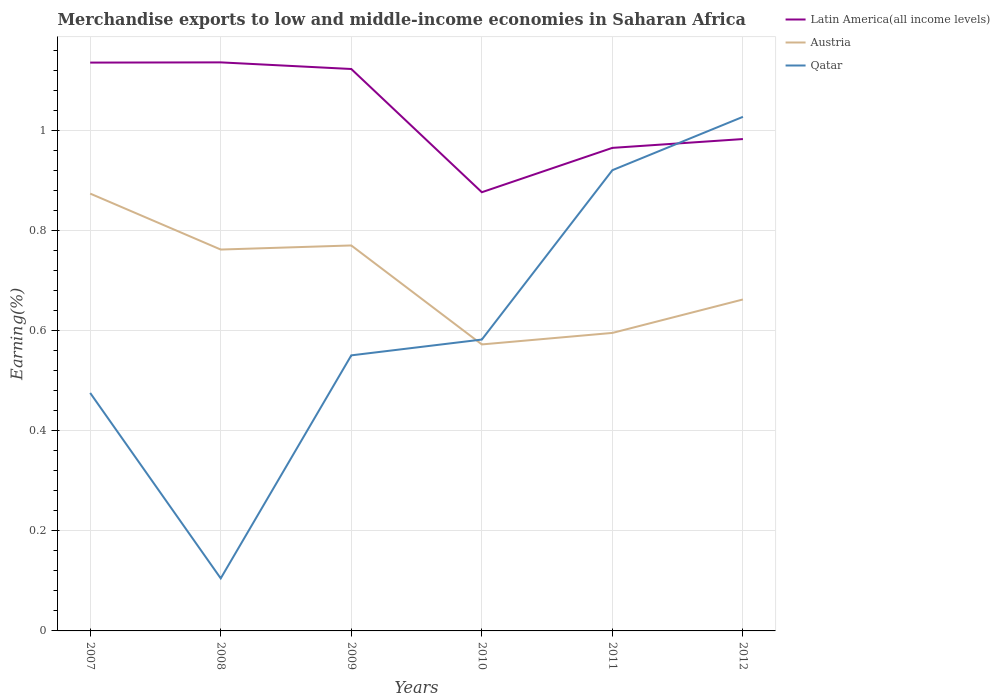Does the line corresponding to Latin America(all income levels) intersect with the line corresponding to Austria?
Provide a succinct answer. No. Is the number of lines equal to the number of legend labels?
Provide a succinct answer. Yes. Across all years, what is the maximum percentage of amount earned from merchandise exports in Qatar?
Your answer should be very brief. 0.11. In which year was the percentage of amount earned from merchandise exports in Austria maximum?
Your answer should be very brief. 2010. What is the total percentage of amount earned from merchandise exports in Austria in the graph?
Offer a very short reply. 0.11. What is the difference between the highest and the second highest percentage of amount earned from merchandise exports in Austria?
Give a very brief answer. 0.3. What is the difference between the highest and the lowest percentage of amount earned from merchandise exports in Austria?
Give a very brief answer. 3. What is the difference between two consecutive major ticks on the Y-axis?
Offer a very short reply. 0.2. Does the graph contain grids?
Provide a succinct answer. Yes. How many legend labels are there?
Provide a short and direct response. 3. What is the title of the graph?
Your answer should be compact. Merchandise exports to low and middle-income economies in Saharan Africa. Does "Hungary" appear as one of the legend labels in the graph?
Ensure brevity in your answer.  No. What is the label or title of the Y-axis?
Your response must be concise. Earning(%). What is the Earning(%) of Latin America(all income levels) in 2007?
Offer a terse response. 1.14. What is the Earning(%) in Austria in 2007?
Offer a terse response. 0.87. What is the Earning(%) in Qatar in 2007?
Ensure brevity in your answer.  0.48. What is the Earning(%) in Latin America(all income levels) in 2008?
Keep it short and to the point. 1.14. What is the Earning(%) in Austria in 2008?
Your answer should be compact. 0.76. What is the Earning(%) of Qatar in 2008?
Keep it short and to the point. 0.11. What is the Earning(%) of Latin America(all income levels) in 2009?
Ensure brevity in your answer.  1.12. What is the Earning(%) of Austria in 2009?
Offer a very short reply. 0.77. What is the Earning(%) of Qatar in 2009?
Offer a very short reply. 0.55. What is the Earning(%) of Latin America(all income levels) in 2010?
Make the answer very short. 0.88. What is the Earning(%) of Austria in 2010?
Your response must be concise. 0.57. What is the Earning(%) in Qatar in 2010?
Provide a short and direct response. 0.58. What is the Earning(%) of Latin America(all income levels) in 2011?
Provide a short and direct response. 0.97. What is the Earning(%) of Austria in 2011?
Offer a very short reply. 0.6. What is the Earning(%) of Qatar in 2011?
Keep it short and to the point. 0.92. What is the Earning(%) of Latin America(all income levels) in 2012?
Provide a short and direct response. 0.98. What is the Earning(%) in Austria in 2012?
Your answer should be compact. 0.66. What is the Earning(%) of Qatar in 2012?
Give a very brief answer. 1.03. Across all years, what is the maximum Earning(%) in Latin America(all income levels)?
Your answer should be very brief. 1.14. Across all years, what is the maximum Earning(%) in Austria?
Make the answer very short. 0.87. Across all years, what is the maximum Earning(%) in Qatar?
Your answer should be compact. 1.03. Across all years, what is the minimum Earning(%) of Latin America(all income levels)?
Provide a short and direct response. 0.88. Across all years, what is the minimum Earning(%) of Austria?
Give a very brief answer. 0.57. Across all years, what is the minimum Earning(%) of Qatar?
Ensure brevity in your answer.  0.11. What is the total Earning(%) of Latin America(all income levels) in the graph?
Provide a succinct answer. 6.22. What is the total Earning(%) of Austria in the graph?
Provide a succinct answer. 4.24. What is the total Earning(%) in Qatar in the graph?
Provide a succinct answer. 3.66. What is the difference between the Earning(%) in Latin America(all income levels) in 2007 and that in 2008?
Provide a short and direct response. -0. What is the difference between the Earning(%) in Austria in 2007 and that in 2008?
Provide a short and direct response. 0.11. What is the difference between the Earning(%) of Qatar in 2007 and that in 2008?
Make the answer very short. 0.37. What is the difference between the Earning(%) of Latin America(all income levels) in 2007 and that in 2009?
Your answer should be compact. 0.01. What is the difference between the Earning(%) of Austria in 2007 and that in 2009?
Keep it short and to the point. 0.1. What is the difference between the Earning(%) in Qatar in 2007 and that in 2009?
Give a very brief answer. -0.08. What is the difference between the Earning(%) in Latin America(all income levels) in 2007 and that in 2010?
Make the answer very short. 0.26. What is the difference between the Earning(%) in Austria in 2007 and that in 2010?
Your answer should be compact. 0.3. What is the difference between the Earning(%) in Qatar in 2007 and that in 2010?
Make the answer very short. -0.11. What is the difference between the Earning(%) in Latin America(all income levels) in 2007 and that in 2011?
Your answer should be compact. 0.17. What is the difference between the Earning(%) in Austria in 2007 and that in 2011?
Make the answer very short. 0.28. What is the difference between the Earning(%) of Qatar in 2007 and that in 2011?
Your response must be concise. -0.45. What is the difference between the Earning(%) of Latin America(all income levels) in 2007 and that in 2012?
Your answer should be very brief. 0.15. What is the difference between the Earning(%) of Austria in 2007 and that in 2012?
Give a very brief answer. 0.21. What is the difference between the Earning(%) in Qatar in 2007 and that in 2012?
Your answer should be compact. -0.55. What is the difference between the Earning(%) of Latin America(all income levels) in 2008 and that in 2009?
Ensure brevity in your answer.  0.01. What is the difference between the Earning(%) in Austria in 2008 and that in 2009?
Provide a succinct answer. -0.01. What is the difference between the Earning(%) of Qatar in 2008 and that in 2009?
Make the answer very short. -0.45. What is the difference between the Earning(%) in Latin America(all income levels) in 2008 and that in 2010?
Provide a short and direct response. 0.26. What is the difference between the Earning(%) of Austria in 2008 and that in 2010?
Keep it short and to the point. 0.19. What is the difference between the Earning(%) of Qatar in 2008 and that in 2010?
Ensure brevity in your answer.  -0.48. What is the difference between the Earning(%) in Latin America(all income levels) in 2008 and that in 2011?
Ensure brevity in your answer.  0.17. What is the difference between the Earning(%) of Austria in 2008 and that in 2011?
Provide a succinct answer. 0.17. What is the difference between the Earning(%) in Qatar in 2008 and that in 2011?
Offer a terse response. -0.82. What is the difference between the Earning(%) of Latin America(all income levels) in 2008 and that in 2012?
Offer a terse response. 0.15. What is the difference between the Earning(%) in Austria in 2008 and that in 2012?
Provide a succinct answer. 0.1. What is the difference between the Earning(%) of Qatar in 2008 and that in 2012?
Your response must be concise. -0.92. What is the difference between the Earning(%) in Latin America(all income levels) in 2009 and that in 2010?
Provide a succinct answer. 0.25. What is the difference between the Earning(%) of Austria in 2009 and that in 2010?
Your response must be concise. 0.2. What is the difference between the Earning(%) of Qatar in 2009 and that in 2010?
Make the answer very short. -0.03. What is the difference between the Earning(%) of Latin America(all income levels) in 2009 and that in 2011?
Make the answer very short. 0.16. What is the difference between the Earning(%) of Austria in 2009 and that in 2011?
Ensure brevity in your answer.  0.17. What is the difference between the Earning(%) of Qatar in 2009 and that in 2011?
Your answer should be compact. -0.37. What is the difference between the Earning(%) of Latin America(all income levels) in 2009 and that in 2012?
Offer a very short reply. 0.14. What is the difference between the Earning(%) of Austria in 2009 and that in 2012?
Ensure brevity in your answer.  0.11. What is the difference between the Earning(%) in Qatar in 2009 and that in 2012?
Provide a short and direct response. -0.48. What is the difference between the Earning(%) of Latin America(all income levels) in 2010 and that in 2011?
Provide a short and direct response. -0.09. What is the difference between the Earning(%) in Austria in 2010 and that in 2011?
Your answer should be very brief. -0.02. What is the difference between the Earning(%) in Qatar in 2010 and that in 2011?
Keep it short and to the point. -0.34. What is the difference between the Earning(%) of Latin America(all income levels) in 2010 and that in 2012?
Make the answer very short. -0.11. What is the difference between the Earning(%) in Austria in 2010 and that in 2012?
Keep it short and to the point. -0.09. What is the difference between the Earning(%) of Qatar in 2010 and that in 2012?
Provide a succinct answer. -0.45. What is the difference between the Earning(%) in Latin America(all income levels) in 2011 and that in 2012?
Provide a short and direct response. -0.02. What is the difference between the Earning(%) in Austria in 2011 and that in 2012?
Provide a short and direct response. -0.07. What is the difference between the Earning(%) in Qatar in 2011 and that in 2012?
Give a very brief answer. -0.11. What is the difference between the Earning(%) of Latin America(all income levels) in 2007 and the Earning(%) of Austria in 2008?
Your answer should be compact. 0.37. What is the difference between the Earning(%) in Latin America(all income levels) in 2007 and the Earning(%) in Qatar in 2008?
Your response must be concise. 1.03. What is the difference between the Earning(%) in Austria in 2007 and the Earning(%) in Qatar in 2008?
Ensure brevity in your answer.  0.77. What is the difference between the Earning(%) of Latin America(all income levels) in 2007 and the Earning(%) of Austria in 2009?
Offer a very short reply. 0.37. What is the difference between the Earning(%) in Latin America(all income levels) in 2007 and the Earning(%) in Qatar in 2009?
Make the answer very short. 0.59. What is the difference between the Earning(%) in Austria in 2007 and the Earning(%) in Qatar in 2009?
Provide a succinct answer. 0.32. What is the difference between the Earning(%) in Latin America(all income levels) in 2007 and the Earning(%) in Austria in 2010?
Your answer should be very brief. 0.56. What is the difference between the Earning(%) of Latin America(all income levels) in 2007 and the Earning(%) of Qatar in 2010?
Provide a short and direct response. 0.55. What is the difference between the Earning(%) in Austria in 2007 and the Earning(%) in Qatar in 2010?
Your response must be concise. 0.29. What is the difference between the Earning(%) in Latin America(all income levels) in 2007 and the Earning(%) in Austria in 2011?
Offer a terse response. 0.54. What is the difference between the Earning(%) of Latin America(all income levels) in 2007 and the Earning(%) of Qatar in 2011?
Offer a very short reply. 0.21. What is the difference between the Earning(%) in Austria in 2007 and the Earning(%) in Qatar in 2011?
Offer a terse response. -0.05. What is the difference between the Earning(%) in Latin America(all income levels) in 2007 and the Earning(%) in Austria in 2012?
Your answer should be compact. 0.47. What is the difference between the Earning(%) of Latin America(all income levels) in 2007 and the Earning(%) of Qatar in 2012?
Keep it short and to the point. 0.11. What is the difference between the Earning(%) of Austria in 2007 and the Earning(%) of Qatar in 2012?
Your answer should be compact. -0.15. What is the difference between the Earning(%) in Latin America(all income levels) in 2008 and the Earning(%) in Austria in 2009?
Provide a short and direct response. 0.37. What is the difference between the Earning(%) in Latin America(all income levels) in 2008 and the Earning(%) in Qatar in 2009?
Your answer should be very brief. 0.59. What is the difference between the Earning(%) of Austria in 2008 and the Earning(%) of Qatar in 2009?
Ensure brevity in your answer.  0.21. What is the difference between the Earning(%) in Latin America(all income levels) in 2008 and the Earning(%) in Austria in 2010?
Ensure brevity in your answer.  0.56. What is the difference between the Earning(%) of Latin America(all income levels) in 2008 and the Earning(%) of Qatar in 2010?
Make the answer very short. 0.55. What is the difference between the Earning(%) of Austria in 2008 and the Earning(%) of Qatar in 2010?
Ensure brevity in your answer.  0.18. What is the difference between the Earning(%) of Latin America(all income levels) in 2008 and the Earning(%) of Austria in 2011?
Make the answer very short. 0.54. What is the difference between the Earning(%) in Latin America(all income levels) in 2008 and the Earning(%) in Qatar in 2011?
Offer a very short reply. 0.22. What is the difference between the Earning(%) in Austria in 2008 and the Earning(%) in Qatar in 2011?
Your answer should be very brief. -0.16. What is the difference between the Earning(%) of Latin America(all income levels) in 2008 and the Earning(%) of Austria in 2012?
Ensure brevity in your answer.  0.47. What is the difference between the Earning(%) of Latin America(all income levels) in 2008 and the Earning(%) of Qatar in 2012?
Provide a short and direct response. 0.11. What is the difference between the Earning(%) in Austria in 2008 and the Earning(%) in Qatar in 2012?
Your answer should be very brief. -0.27. What is the difference between the Earning(%) of Latin America(all income levels) in 2009 and the Earning(%) of Austria in 2010?
Make the answer very short. 0.55. What is the difference between the Earning(%) in Latin America(all income levels) in 2009 and the Earning(%) in Qatar in 2010?
Provide a succinct answer. 0.54. What is the difference between the Earning(%) of Austria in 2009 and the Earning(%) of Qatar in 2010?
Keep it short and to the point. 0.19. What is the difference between the Earning(%) of Latin America(all income levels) in 2009 and the Earning(%) of Austria in 2011?
Your answer should be compact. 0.53. What is the difference between the Earning(%) of Latin America(all income levels) in 2009 and the Earning(%) of Qatar in 2011?
Offer a terse response. 0.2. What is the difference between the Earning(%) of Austria in 2009 and the Earning(%) of Qatar in 2011?
Provide a succinct answer. -0.15. What is the difference between the Earning(%) in Latin America(all income levels) in 2009 and the Earning(%) in Austria in 2012?
Keep it short and to the point. 0.46. What is the difference between the Earning(%) in Latin America(all income levels) in 2009 and the Earning(%) in Qatar in 2012?
Ensure brevity in your answer.  0.1. What is the difference between the Earning(%) in Austria in 2009 and the Earning(%) in Qatar in 2012?
Provide a succinct answer. -0.26. What is the difference between the Earning(%) of Latin America(all income levels) in 2010 and the Earning(%) of Austria in 2011?
Your answer should be very brief. 0.28. What is the difference between the Earning(%) in Latin America(all income levels) in 2010 and the Earning(%) in Qatar in 2011?
Give a very brief answer. -0.04. What is the difference between the Earning(%) of Austria in 2010 and the Earning(%) of Qatar in 2011?
Give a very brief answer. -0.35. What is the difference between the Earning(%) of Latin America(all income levels) in 2010 and the Earning(%) of Austria in 2012?
Keep it short and to the point. 0.21. What is the difference between the Earning(%) of Latin America(all income levels) in 2010 and the Earning(%) of Qatar in 2012?
Offer a very short reply. -0.15. What is the difference between the Earning(%) in Austria in 2010 and the Earning(%) in Qatar in 2012?
Offer a terse response. -0.45. What is the difference between the Earning(%) of Latin America(all income levels) in 2011 and the Earning(%) of Austria in 2012?
Provide a succinct answer. 0.3. What is the difference between the Earning(%) of Latin America(all income levels) in 2011 and the Earning(%) of Qatar in 2012?
Keep it short and to the point. -0.06. What is the difference between the Earning(%) in Austria in 2011 and the Earning(%) in Qatar in 2012?
Your response must be concise. -0.43. What is the average Earning(%) in Latin America(all income levels) per year?
Keep it short and to the point. 1.04. What is the average Earning(%) in Austria per year?
Your answer should be very brief. 0.71. What is the average Earning(%) in Qatar per year?
Your response must be concise. 0.61. In the year 2007, what is the difference between the Earning(%) of Latin America(all income levels) and Earning(%) of Austria?
Offer a very short reply. 0.26. In the year 2007, what is the difference between the Earning(%) of Latin America(all income levels) and Earning(%) of Qatar?
Keep it short and to the point. 0.66. In the year 2007, what is the difference between the Earning(%) of Austria and Earning(%) of Qatar?
Your response must be concise. 0.4. In the year 2008, what is the difference between the Earning(%) in Latin America(all income levels) and Earning(%) in Austria?
Give a very brief answer. 0.37. In the year 2008, what is the difference between the Earning(%) of Latin America(all income levels) and Earning(%) of Qatar?
Provide a short and direct response. 1.03. In the year 2008, what is the difference between the Earning(%) in Austria and Earning(%) in Qatar?
Offer a very short reply. 0.66. In the year 2009, what is the difference between the Earning(%) of Latin America(all income levels) and Earning(%) of Austria?
Your response must be concise. 0.35. In the year 2009, what is the difference between the Earning(%) of Latin America(all income levels) and Earning(%) of Qatar?
Your response must be concise. 0.57. In the year 2009, what is the difference between the Earning(%) in Austria and Earning(%) in Qatar?
Provide a short and direct response. 0.22. In the year 2010, what is the difference between the Earning(%) of Latin America(all income levels) and Earning(%) of Austria?
Your answer should be compact. 0.3. In the year 2010, what is the difference between the Earning(%) in Latin America(all income levels) and Earning(%) in Qatar?
Provide a succinct answer. 0.29. In the year 2010, what is the difference between the Earning(%) in Austria and Earning(%) in Qatar?
Your answer should be compact. -0.01. In the year 2011, what is the difference between the Earning(%) in Latin America(all income levels) and Earning(%) in Austria?
Your response must be concise. 0.37. In the year 2011, what is the difference between the Earning(%) in Latin America(all income levels) and Earning(%) in Qatar?
Make the answer very short. 0.04. In the year 2011, what is the difference between the Earning(%) in Austria and Earning(%) in Qatar?
Ensure brevity in your answer.  -0.33. In the year 2012, what is the difference between the Earning(%) in Latin America(all income levels) and Earning(%) in Austria?
Keep it short and to the point. 0.32. In the year 2012, what is the difference between the Earning(%) in Latin America(all income levels) and Earning(%) in Qatar?
Provide a short and direct response. -0.04. In the year 2012, what is the difference between the Earning(%) in Austria and Earning(%) in Qatar?
Make the answer very short. -0.36. What is the ratio of the Earning(%) in Latin America(all income levels) in 2007 to that in 2008?
Your answer should be very brief. 1. What is the ratio of the Earning(%) of Austria in 2007 to that in 2008?
Your response must be concise. 1.15. What is the ratio of the Earning(%) in Qatar in 2007 to that in 2008?
Offer a terse response. 4.53. What is the ratio of the Earning(%) in Latin America(all income levels) in 2007 to that in 2009?
Keep it short and to the point. 1.01. What is the ratio of the Earning(%) in Austria in 2007 to that in 2009?
Your answer should be compact. 1.13. What is the ratio of the Earning(%) of Qatar in 2007 to that in 2009?
Make the answer very short. 0.86. What is the ratio of the Earning(%) in Latin America(all income levels) in 2007 to that in 2010?
Provide a short and direct response. 1.3. What is the ratio of the Earning(%) in Austria in 2007 to that in 2010?
Your response must be concise. 1.53. What is the ratio of the Earning(%) in Qatar in 2007 to that in 2010?
Give a very brief answer. 0.82. What is the ratio of the Earning(%) in Latin America(all income levels) in 2007 to that in 2011?
Offer a very short reply. 1.18. What is the ratio of the Earning(%) in Austria in 2007 to that in 2011?
Your response must be concise. 1.47. What is the ratio of the Earning(%) of Qatar in 2007 to that in 2011?
Keep it short and to the point. 0.52. What is the ratio of the Earning(%) in Latin America(all income levels) in 2007 to that in 2012?
Make the answer very short. 1.16. What is the ratio of the Earning(%) of Austria in 2007 to that in 2012?
Offer a very short reply. 1.32. What is the ratio of the Earning(%) in Qatar in 2007 to that in 2012?
Make the answer very short. 0.46. What is the ratio of the Earning(%) of Latin America(all income levels) in 2008 to that in 2009?
Offer a very short reply. 1.01. What is the ratio of the Earning(%) of Qatar in 2008 to that in 2009?
Keep it short and to the point. 0.19. What is the ratio of the Earning(%) in Latin America(all income levels) in 2008 to that in 2010?
Your answer should be compact. 1.3. What is the ratio of the Earning(%) in Austria in 2008 to that in 2010?
Give a very brief answer. 1.33. What is the ratio of the Earning(%) in Qatar in 2008 to that in 2010?
Make the answer very short. 0.18. What is the ratio of the Earning(%) of Latin America(all income levels) in 2008 to that in 2011?
Your response must be concise. 1.18. What is the ratio of the Earning(%) in Austria in 2008 to that in 2011?
Provide a short and direct response. 1.28. What is the ratio of the Earning(%) of Qatar in 2008 to that in 2011?
Your response must be concise. 0.11. What is the ratio of the Earning(%) in Latin America(all income levels) in 2008 to that in 2012?
Make the answer very short. 1.16. What is the ratio of the Earning(%) in Austria in 2008 to that in 2012?
Make the answer very short. 1.15. What is the ratio of the Earning(%) in Qatar in 2008 to that in 2012?
Give a very brief answer. 0.1. What is the ratio of the Earning(%) of Latin America(all income levels) in 2009 to that in 2010?
Your answer should be compact. 1.28. What is the ratio of the Earning(%) in Austria in 2009 to that in 2010?
Your response must be concise. 1.35. What is the ratio of the Earning(%) in Qatar in 2009 to that in 2010?
Provide a short and direct response. 0.95. What is the ratio of the Earning(%) of Latin America(all income levels) in 2009 to that in 2011?
Offer a terse response. 1.16. What is the ratio of the Earning(%) in Austria in 2009 to that in 2011?
Your answer should be very brief. 1.29. What is the ratio of the Earning(%) in Qatar in 2009 to that in 2011?
Make the answer very short. 0.6. What is the ratio of the Earning(%) in Latin America(all income levels) in 2009 to that in 2012?
Provide a succinct answer. 1.14. What is the ratio of the Earning(%) in Austria in 2009 to that in 2012?
Keep it short and to the point. 1.16. What is the ratio of the Earning(%) in Qatar in 2009 to that in 2012?
Ensure brevity in your answer.  0.54. What is the ratio of the Earning(%) in Latin America(all income levels) in 2010 to that in 2011?
Keep it short and to the point. 0.91. What is the ratio of the Earning(%) of Austria in 2010 to that in 2011?
Your answer should be compact. 0.96. What is the ratio of the Earning(%) in Qatar in 2010 to that in 2011?
Your answer should be very brief. 0.63. What is the ratio of the Earning(%) in Latin America(all income levels) in 2010 to that in 2012?
Ensure brevity in your answer.  0.89. What is the ratio of the Earning(%) in Austria in 2010 to that in 2012?
Offer a terse response. 0.86. What is the ratio of the Earning(%) of Qatar in 2010 to that in 2012?
Provide a short and direct response. 0.57. What is the ratio of the Earning(%) of Latin America(all income levels) in 2011 to that in 2012?
Make the answer very short. 0.98. What is the ratio of the Earning(%) in Austria in 2011 to that in 2012?
Provide a short and direct response. 0.9. What is the ratio of the Earning(%) in Qatar in 2011 to that in 2012?
Provide a short and direct response. 0.9. What is the difference between the highest and the second highest Earning(%) of Latin America(all income levels)?
Offer a very short reply. 0. What is the difference between the highest and the second highest Earning(%) of Austria?
Your response must be concise. 0.1. What is the difference between the highest and the second highest Earning(%) in Qatar?
Your answer should be very brief. 0.11. What is the difference between the highest and the lowest Earning(%) in Latin America(all income levels)?
Give a very brief answer. 0.26. What is the difference between the highest and the lowest Earning(%) of Austria?
Make the answer very short. 0.3. What is the difference between the highest and the lowest Earning(%) of Qatar?
Your response must be concise. 0.92. 